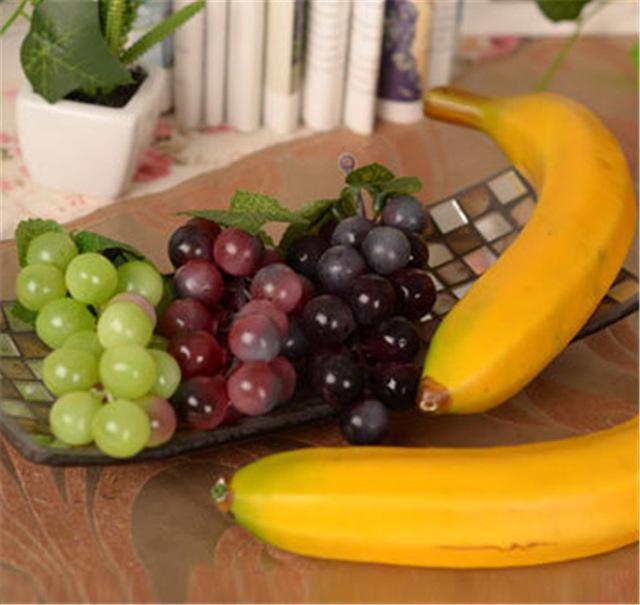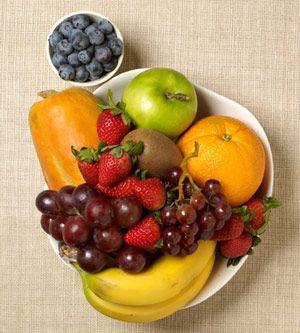The first image is the image on the left, the second image is the image on the right. For the images shown, is this caption "There are red grapes and green grapes beside each-other in one of the images." true? Answer yes or no. Yes. The first image is the image on the left, the second image is the image on the right. Considering the images on both sides, is "One of the images has at least one apple." valid? Answer yes or no. Yes. 